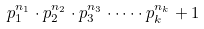<formula> <loc_0><loc_0><loc_500><loc_500>p _ { 1 } ^ { n _ { 1 } } \cdot p _ { 2 } ^ { n _ { 2 } } \cdot p _ { 3 } ^ { n _ { 3 } } \cdot \dots \cdot p _ { k } ^ { n _ { k } } + 1</formula> 